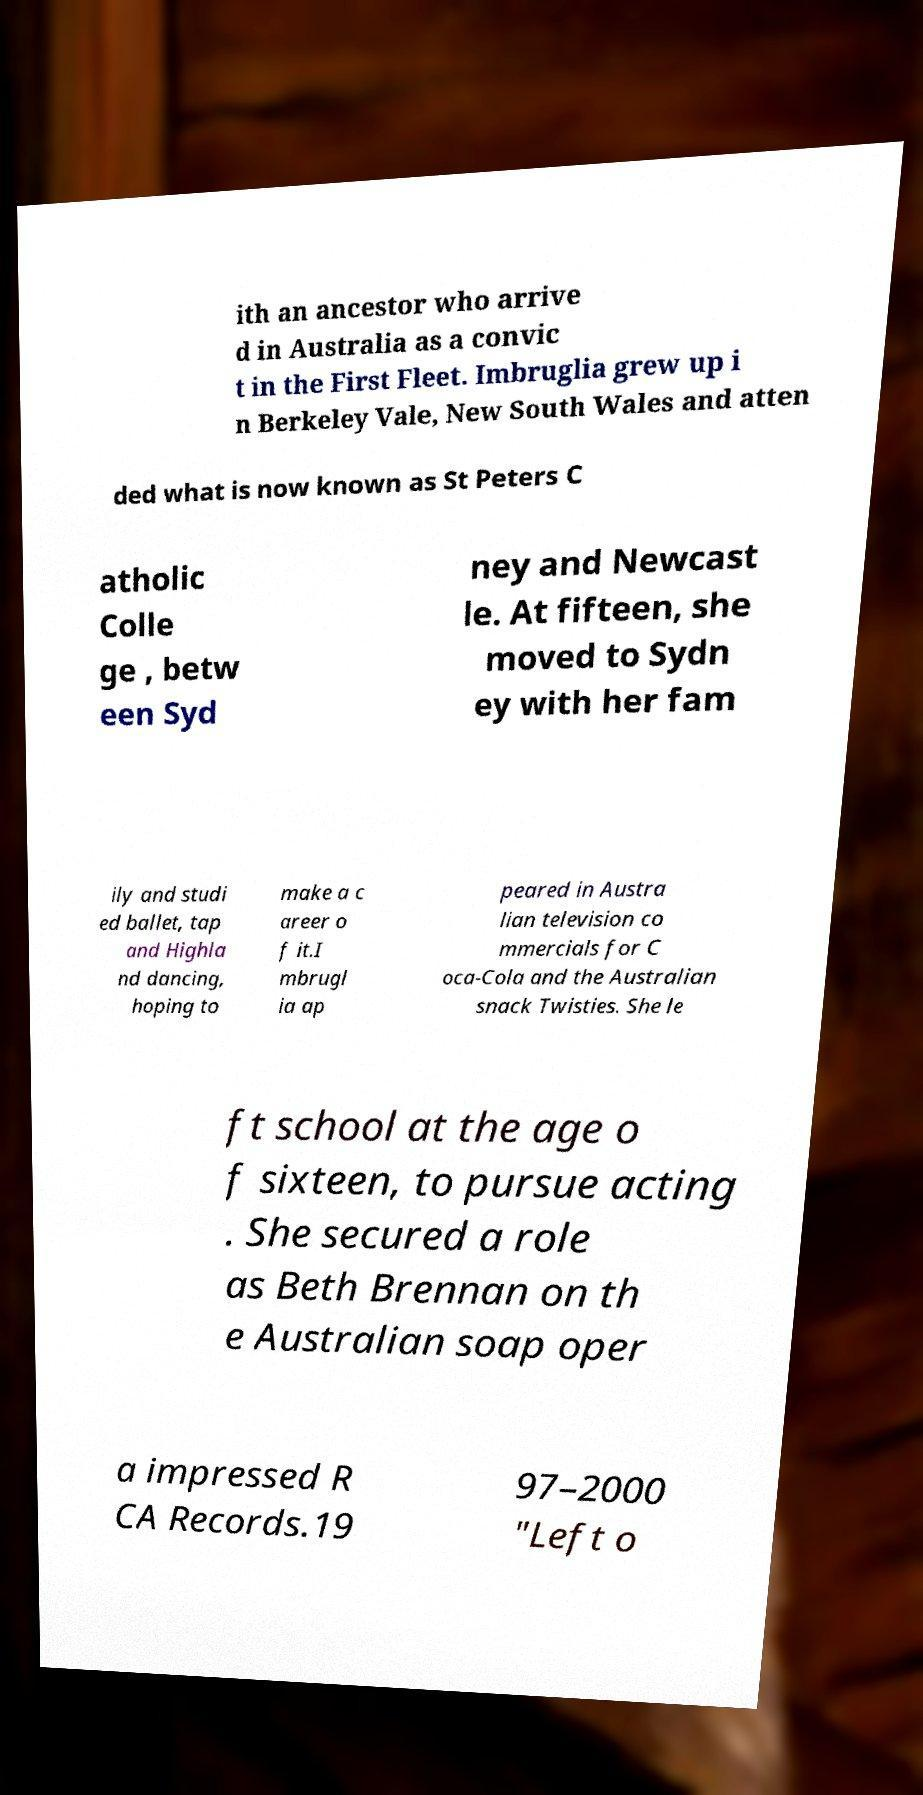I need the written content from this picture converted into text. Can you do that? ith an ancestor who arrive d in Australia as a convic t in the First Fleet. Imbruglia grew up i n Berkeley Vale, New South Wales and atten ded what is now known as St Peters C atholic Colle ge , betw een Syd ney and Newcast le. At fifteen, she moved to Sydn ey with her fam ily and studi ed ballet, tap and Highla nd dancing, hoping to make a c areer o f it.I mbrugl ia ap peared in Austra lian television co mmercials for C oca-Cola and the Australian snack Twisties. She le ft school at the age o f sixteen, to pursue acting . She secured a role as Beth Brennan on th e Australian soap oper a impressed R CA Records.19 97–2000 "Left o 